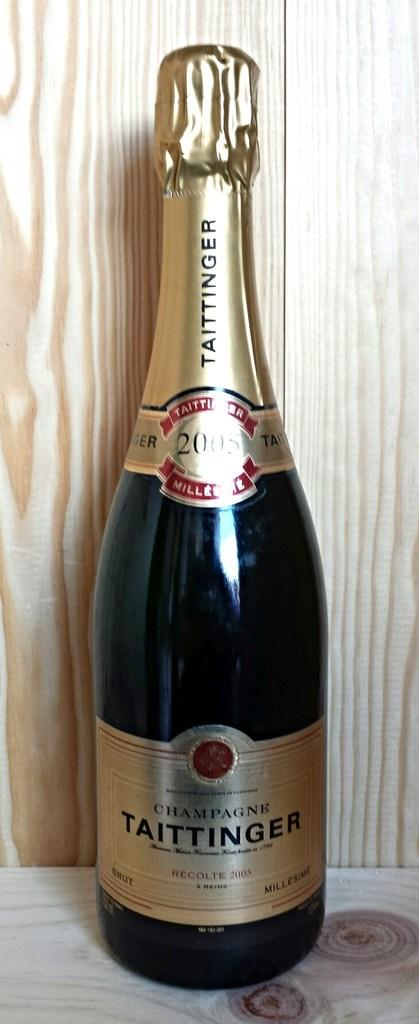<image>
Write a terse but informative summary of the picture. A bottle of champagne, with a label that says Taittinger. 